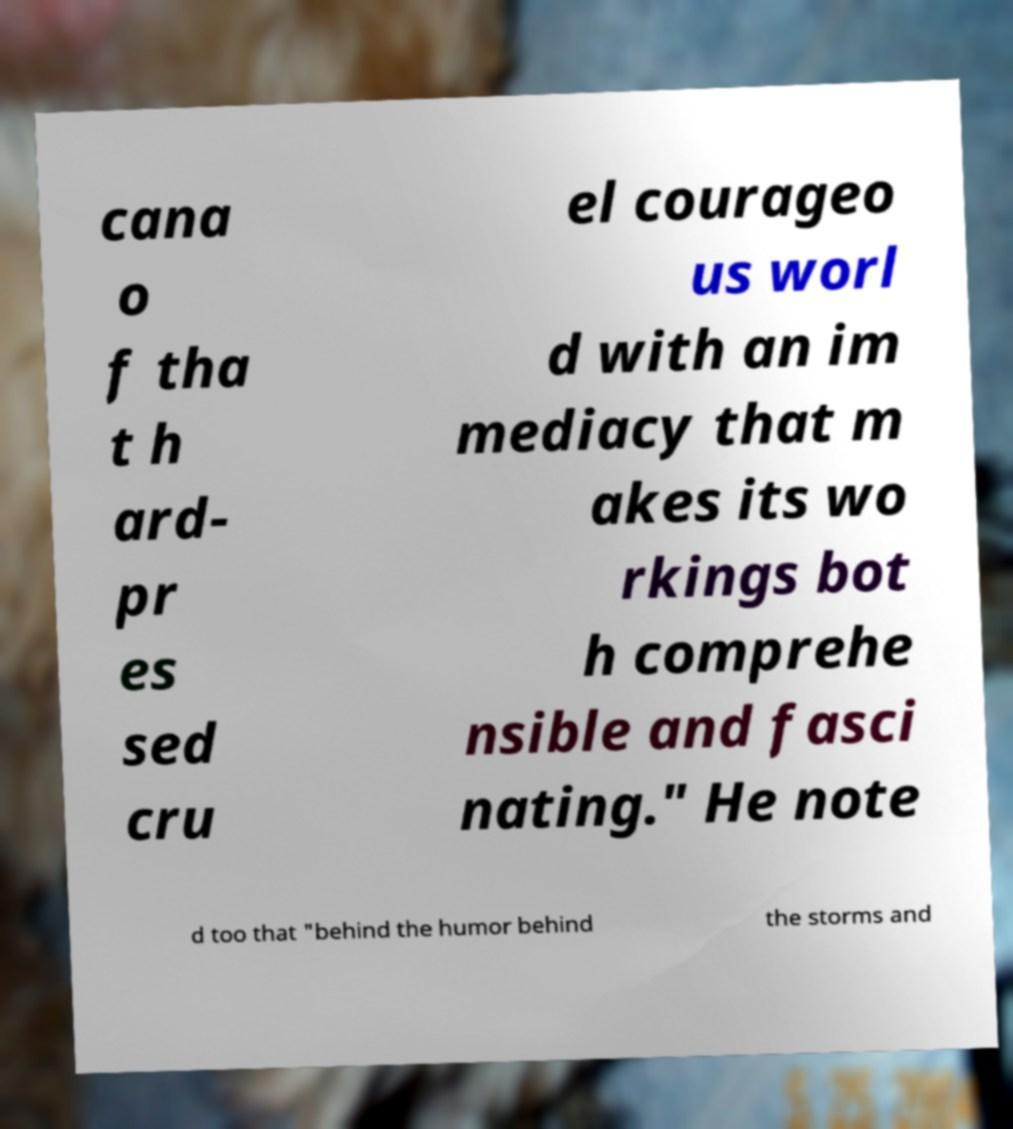For documentation purposes, I need the text within this image transcribed. Could you provide that? cana o f tha t h ard- pr es sed cru el courageo us worl d with an im mediacy that m akes its wo rkings bot h comprehe nsible and fasci nating." He note d too that "behind the humor behind the storms and 